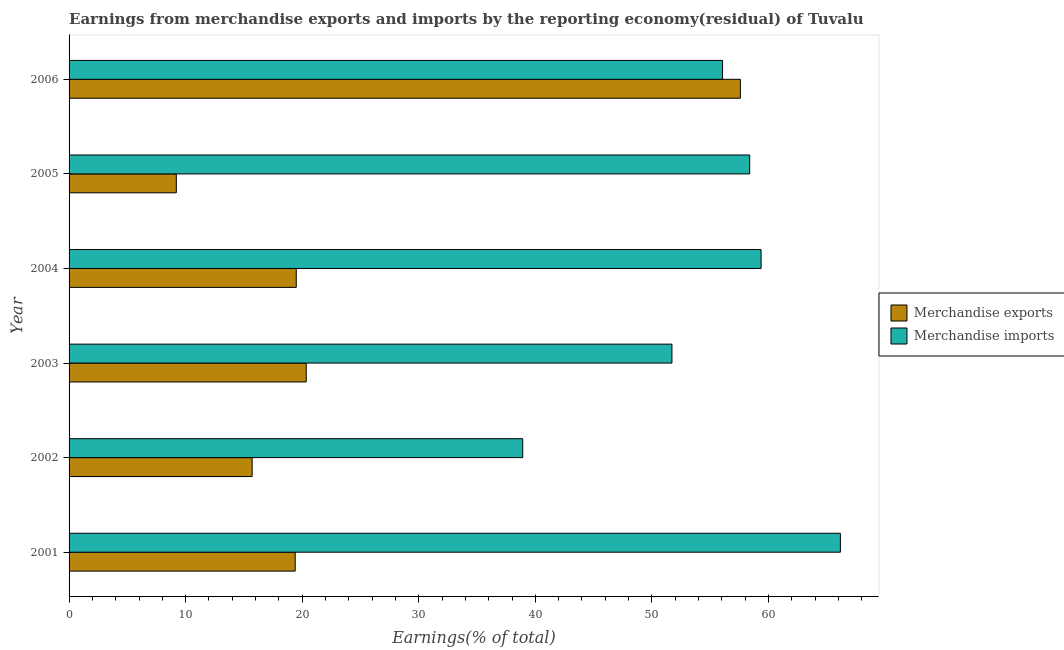How many groups of bars are there?
Ensure brevity in your answer.  6. What is the label of the 5th group of bars from the top?
Your response must be concise. 2002. In how many cases, is the number of bars for a given year not equal to the number of legend labels?
Offer a terse response. 0. What is the earnings from merchandise imports in 2006?
Your answer should be compact. 56.06. Across all years, what is the maximum earnings from merchandise exports?
Provide a short and direct response. 57.59. Across all years, what is the minimum earnings from merchandise exports?
Your answer should be compact. 9.2. In which year was the earnings from merchandise exports minimum?
Provide a succinct answer. 2005. What is the total earnings from merchandise imports in the graph?
Keep it short and to the point. 330.62. What is the difference between the earnings from merchandise exports in 2001 and that in 2005?
Keep it short and to the point. 10.2. What is the difference between the earnings from merchandise imports in 2004 and the earnings from merchandise exports in 2003?
Make the answer very short. 39.02. What is the average earnings from merchandise exports per year?
Your answer should be compact. 23.62. In the year 2006, what is the difference between the earnings from merchandise imports and earnings from merchandise exports?
Offer a terse response. -1.53. What is the ratio of the earnings from merchandise exports in 2003 to that in 2004?
Your answer should be very brief. 1.04. What is the difference between the highest and the second highest earnings from merchandise exports?
Ensure brevity in your answer.  37.24. What is the difference between the highest and the lowest earnings from merchandise exports?
Your response must be concise. 48.39. In how many years, is the earnings from merchandise imports greater than the average earnings from merchandise imports taken over all years?
Provide a succinct answer. 4. What does the 1st bar from the bottom in 2003 represents?
Give a very brief answer. Merchandise exports. How many bars are there?
Offer a terse response. 12. Are all the bars in the graph horizontal?
Give a very brief answer. Yes. Does the graph contain any zero values?
Give a very brief answer. No. Where does the legend appear in the graph?
Your answer should be compact. Center right. What is the title of the graph?
Offer a very short reply. Earnings from merchandise exports and imports by the reporting economy(residual) of Tuvalu. Does "Highest 10% of population" appear as one of the legend labels in the graph?
Make the answer very short. No. What is the label or title of the X-axis?
Offer a very short reply. Earnings(% of total). What is the Earnings(% of total) in Merchandise exports in 2001?
Keep it short and to the point. 19.4. What is the Earnings(% of total) in Merchandise imports in 2001?
Your response must be concise. 66.17. What is the Earnings(% of total) in Merchandise exports in 2002?
Keep it short and to the point. 15.7. What is the Earnings(% of total) of Merchandise imports in 2002?
Provide a succinct answer. 38.92. What is the Earnings(% of total) in Merchandise exports in 2003?
Your answer should be compact. 20.35. What is the Earnings(% of total) of Merchandise imports in 2003?
Provide a succinct answer. 51.72. What is the Earnings(% of total) of Merchandise exports in 2004?
Offer a terse response. 19.49. What is the Earnings(% of total) of Merchandise imports in 2004?
Provide a succinct answer. 59.37. What is the Earnings(% of total) in Merchandise exports in 2005?
Make the answer very short. 9.2. What is the Earnings(% of total) of Merchandise imports in 2005?
Make the answer very short. 58.39. What is the Earnings(% of total) of Merchandise exports in 2006?
Offer a terse response. 57.59. What is the Earnings(% of total) of Merchandise imports in 2006?
Ensure brevity in your answer.  56.06. Across all years, what is the maximum Earnings(% of total) in Merchandise exports?
Your response must be concise. 57.59. Across all years, what is the maximum Earnings(% of total) of Merchandise imports?
Your answer should be compact. 66.17. Across all years, what is the minimum Earnings(% of total) in Merchandise exports?
Your response must be concise. 9.2. Across all years, what is the minimum Earnings(% of total) in Merchandise imports?
Offer a very short reply. 38.92. What is the total Earnings(% of total) in Merchandise exports in the graph?
Your answer should be compact. 141.73. What is the total Earnings(% of total) in Merchandise imports in the graph?
Ensure brevity in your answer.  330.62. What is the difference between the Earnings(% of total) in Merchandise exports in 2001 and that in 2002?
Provide a short and direct response. 3.69. What is the difference between the Earnings(% of total) of Merchandise imports in 2001 and that in 2002?
Make the answer very short. 27.25. What is the difference between the Earnings(% of total) in Merchandise exports in 2001 and that in 2003?
Give a very brief answer. -0.95. What is the difference between the Earnings(% of total) in Merchandise imports in 2001 and that in 2003?
Your answer should be very brief. 14.45. What is the difference between the Earnings(% of total) of Merchandise exports in 2001 and that in 2004?
Give a very brief answer. -0.09. What is the difference between the Earnings(% of total) in Merchandise imports in 2001 and that in 2004?
Give a very brief answer. 6.8. What is the difference between the Earnings(% of total) of Merchandise exports in 2001 and that in 2005?
Keep it short and to the point. 10.2. What is the difference between the Earnings(% of total) of Merchandise imports in 2001 and that in 2005?
Ensure brevity in your answer.  7.78. What is the difference between the Earnings(% of total) of Merchandise exports in 2001 and that in 2006?
Offer a very short reply. -38.19. What is the difference between the Earnings(% of total) of Merchandise imports in 2001 and that in 2006?
Provide a succinct answer. 10.11. What is the difference between the Earnings(% of total) in Merchandise exports in 2002 and that in 2003?
Your answer should be compact. -4.64. What is the difference between the Earnings(% of total) in Merchandise imports in 2002 and that in 2003?
Your answer should be very brief. -12.8. What is the difference between the Earnings(% of total) of Merchandise exports in 2002 and that in 2004?
Make the answer very short. -3.78. What is the difference between the Earnings(% of total) of Merchandise imports in 2002 and that in 2004?
Provide a succinct answer. -20.45. What is the difference between the Earnings(% of total) of Merchandise exports in 2002 and that in 2005?
Offer a terse response. 6.5. What is the difference between the Earnings(% of total) of Merchandise imports in 2002 and that in 2005?
Ensure brevity in your answer.  -19.47. What is the difference between the Earnings(% of total) in Merchandise exports in 2002 and that in 2006?
Give a very brief answer. -41.88. What is the difference between the Earnings(% of total) in Merchandise imports in 2002 and that in 2006?
Make the answer very short. -17.14. What is the difference between the Earnings(% of total) in Merchandise exports in 2003 and that in 2004?
Keep it short and to the point. 0.86. What is the difference between the Earnings(% of total) of Merchandise imports in 2003 and that in 2004?
Your response must be concise. -7.65. What is the difference between the Earnings(% of total) in Merchandise exports in 2003 and that in 2005?
Offer a very short reply. 11.15. What is the difference between the Earnings(% of total) of Merchandise imports in 2003 and that in 2005?
Provide a succinct answer. -6.67. What is the difference between the Earnings(% of total) in Merchandise exports in 2003 and that in 2006?
Your answer should be very brief. -37.24. What is the difference between the Earnings(% of total) in Merchandise imports in 2003 and that in 2006?
Your response must be concise. -4.34. What is the difference between the Earnings(% of total) of Merchandise exports in 2004 and that in 2005?
Your answer should be very brief. 10.29. What is the difference between the Earnings(% of total) of Merchandise imports in 2004 and that in 2005?
Provide a short and direct response. 0.98. What is the difference between the Earnings(% of total) in Merchandise exports in 2004 and that in 2006?
Your answer should be very brief. -38.1. What is the difference between the Earnings(% of total) of Merchandise imports in 2004 and that in 2006?
Give a very brief answer. 3.31. What is the difference between the Earnings(% of total) in Merchandise exports in 2005 and that in 2006?
Your response must be concise. -48.39. What is the difference between the Earnings(% of total) of Merchandise imports in 2005 and that in 2006?
Make the answer very short. 2.33. What is the difference between the Earnings(% of total) in Merchandise exports in 2001 and the Earnings(% of total) in Merchandise imports in 2002?
Offer a terse response. -19.52. What is the difference between the Earnings(% of total) in Merchandise exports in 2001 and the Earnings(% of total) in Merchandise imports in 2003?
Your answer should be very brief. -32.32. What is the difference between the Earnings(% of total) of Merchandise exports in 2001 and the Earnings(% of total) of Merchandise imports in 2004?
Provide a succinct answer. -39.97. What is the difference between the Earnings(% of total) of Merchandise exports in 2001 and the Earnings(% of total) of Merchandise imports in 2005?
Offer a very short reply. -38.99. What is the difference between the Earnings(% of total) of Merchandise exports in 2001 and the Earnings(% of total) of Merchandise imports in 2006?
Ensure brevity in your answer.  -36.66. What is the difference between the Earnings(% of total) in Merchandise exports in 2002 and the Earnings(% of total) in Merchandise imports in 2003?
Your answer should be very brief. -36.01. What is the difference between the Earnings(% of total) in Merchandise exports in 2002 and the Earnings(% of total) in Merchandise imports in 2004?
Your response must be concise. -43.66. What is the difference between the Earnings(% of total) of Merchandise exports in 2002 and the Earnings(% of total) of Merchandise imports in 2005?
Provide a succinct answer. -42.68. What is the difference between the Earnings(% of total) in Merchandise exports in 2002 and the Earnings(% of total) in Merchandise imports in 2006?
Keep it short and to the point. -40.36. What is the difference between the Earnings(% of total) in Merchandise exports in 2003 and the Earnings(% of total) in Merchandise imports in 2004?
Give a very brief answer. -39.02. What is the difference between the Earnings(% of total) in Merchandise exports in 2003 and the Earnings(% of total) in Merchandise imports in 2005?
Ensure brevity in your answer.  -38.04. What is the difference between the Earnings(% of total) of Merchandise exports in 2003 and the Earnings(% of total) of Merchandise imports in 2006?
Make the answer very short. -35.71. What is the difference between the Earnings(% of total) of Merchandise exports in 2004 and the Earnings(% of total) of Merchandise imports in 2005?
Your answer should be very brief. -38.9. What is the difference between the Earnings(% of total) in Merchandise exports in 2004 and the Earnings(% of total) in Merchandise imports in 2006?
Provide a succinct answer. -36.57. What is the difference between the Earnings(% of total) in Merchandise exports in 2005 and the Earnings(% of total) in Merchandise imports in 2006?
Provide a succinct answer. -46.86. What is the average Earnings(% of total) of Merchandise exports per year?
Your answer should be compact. 23.62. What is the average Earnings(% of total) in Merchandise imports per year?
Keep it short and to the point. 55.1. In the year 2001, what is the difference between the Earnings(% of total) in Merchandise exports and Earnings(% of total) in Merchandise imports?
Offer a very short reply. -46.77. In the year 2002, what is the difference between the Earnings(% of total) in Merchandise exports and Earnings(% of total) in Merchandise imports?
Make the answer very short. -23.21. In the year 2003, what is the difference between the Earnings(% of total) in Merchandise exports and Earnings(% of total) in Merchandise imports?
Make the answer very short. -31.37. In the year 2004, what is the difference between the Earnings(% of total) in Merchandise exports and Earnings(% of total) in Merchandise imports?
Provide a short and direct response. -39.88. In the year 2005, what is the difference between the Earnings(% of total) of Merchandise exports and Earnings(% of total) of Merchandise imports?
Your answer should be very brief. -49.19. In the year 2006, what is the difference between the Earnings(% of total) in Merchandise exports and Earnings(% of total) in Merchandise imports?
Ensure brevity in your answer.  1.53. What is the ratio of the Earnings(% of total) in Merchandise exports in 2001 to that in 2002?
Make the answer very short. 1.24. What is the ratio of the Earnings(% of total) of Merchandise imports in 2001 to that in 2002?
Ensure brevity in your answer.  1.7. What is the ratio of the Earnings(% of total) of Merchandise exports in 2001 to that in 2003?
Keep it short and to the point. 0.95. What is the ratio of the Earnings(% of total) of Merchandise imports in 2001 to that in 2003?
Provide a succinct answer. 1.28. What is the ratio of the Earnings(% of total) in Merchandise exports in 2001 to that in 2004?
Offer a terse response. 1. What is the ratio of the Earnings(% of total) of Merchandise imports in 2001 to that in 2004?
Ensure brevity in your answer.  1.11. What is the ratio of the Earnings(% of total) in Merchandise exports in 2001 to that in 2005?
Your answer should be compact. 2.11. What is the ratio of the Earnings(% of total) of Merchandise imports in 2001 to that in 2005?
Your answer should be compact. 1.13. What is the ratio of the Earnings(% of total) of Merchandise exports in 2001 to that in 2006?
Make the answer very short. 0.34. What is the ratio of the Earnings(% of total) in Merchandise imports in 2001 to that in 2006?
Give a very brief answer. 1.18. What is the ratio of the Earnings(% of total) of Merchandise exports in 2002 to that in 2003?
Provide a short and direct response. 0.77. What is the ratio of the Earnings(% of total) of Merchandise imports in 2002 to that in 2003?
Ensure brevity in your answer.  0.75. What is the ratio of the Earnings(% of total) of Merchandise exports in 2002 to that in 2004?
Your answer should be very brief. 0.81. What is the ratio of the Earnings(% of total) in Merchandise imports in 2002 to that in 2004?
Provide a succinct answer. 0.66. What is the ratio of the Earnings(% of total) of Merchandise exports in 2002 to that in 2005?
Make the answer very short. 1.71. What is the ratio of the Earnings(% of total) in Merchandise imports in 2002 to that in 2005?
Your answer should be very brief. 0.67. What is the ratio of the Earnings(% of total) in Merchandise exports in 2002 to that in 2006?
Provide a short and direct response. 0.27. What is the ratio of the Earnings(% of total) in Merchandise imports in 2002 to that in 2006?
Your answer should be compact. 0.69. What is the ratio of the Earnings(% of total) of Merchandise exports in 2003 to that in 2004?
Offer a terse response. 1.04. What is the ratio of the Earnings(% of total) in Merchandise imports in 2003 to that in 2004?
Make the answer very short. 0.87. What is the ratio of the Earnings(% of total) in Merchandise exports in 2003 to that in 2005?
Give a very brief answer. 2.21. What is the ratio of the Earnings(% of total) in Merchandise imports in 2003 to that in 2005?
Make the answer very short. 0.89. What is the ratio of the Earnings(% of total) of Merchandise exports in 2003 to that in 2006?
Your response must be concise. 0.35. What is the ratio of the Earnings(% of total) in Merchandise imports in 2003 to that in 2006?
Make the answer very short. 0.92. What is the ratio of the Earnings(% of total) in Merchandise exports in 2004 to that in 2005?
Your response must be concise. 2.12. What is the ratio of the Earnings(% of total) of Merchandise imports in 2004 to that in 2005?
Your answer should be compact. 1.02. What is the ratio of the Earnings(% of total) in Merchandise exports in 2004 to that in 2006?
Your answer should be very brief. 0.34. What is the ratio of the Earnings(% of total) of Merchandise imports in 2004 to that in 2006?
Your answer should be very brief. 1.06. What is the ratio of the Earnings(% of total) of Merchandise exports in 2005 to that in 2006?
Your response must be concise. 0.16. What is the ratio of the Earnings(% of total) in Merchandise imports in 2005 to that in 2006?
Offer a terse response. 1.04. What is the difference between the highest and the second highest Earnings(% of total) of Merchandise exports?
Give a very brief answer. 37.24. What is the difference between the highest and the second highest Earnings(% of total) in Merchandise imports?
Offer a terse response. 6.8. What is the difference between the highest and the lowest Earnings(% of total) of Merchandise exports?
Offer a very short reply. 48.39. What is the difference between the highest and the lowest Earnings(% of total) of Merchandise imports?
Give a very brief answer. 27.25. 